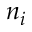<formula> <loc_0><loc_0><loc_500><loc_500>n _ { i }</formula> 